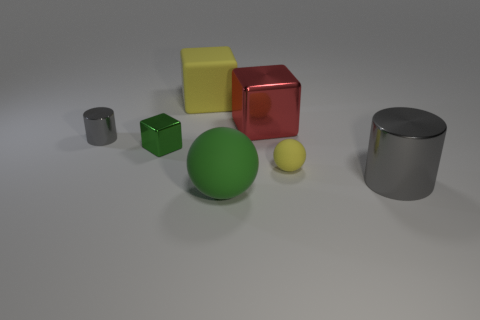Subtract all big blocks. How many blocks are left? 1 Add 1 gray matte cylinders. How many objects exist? 8 Subtract all balls. How many objects are left? 5 Subtract all tiny green metallic blocks. Subtract all matte objects. How many objects are left? 3 Add 2 large red metal things. How many large red metal things are left? 3 Add 5 big gray metallic spheres. How many big gray metallic spheres exist? 5 Subtract 0 green cylinders. How many objects are left? 7 Subtract all gray cubes. Subtract all cyan balls. How many cubes are left? 3 